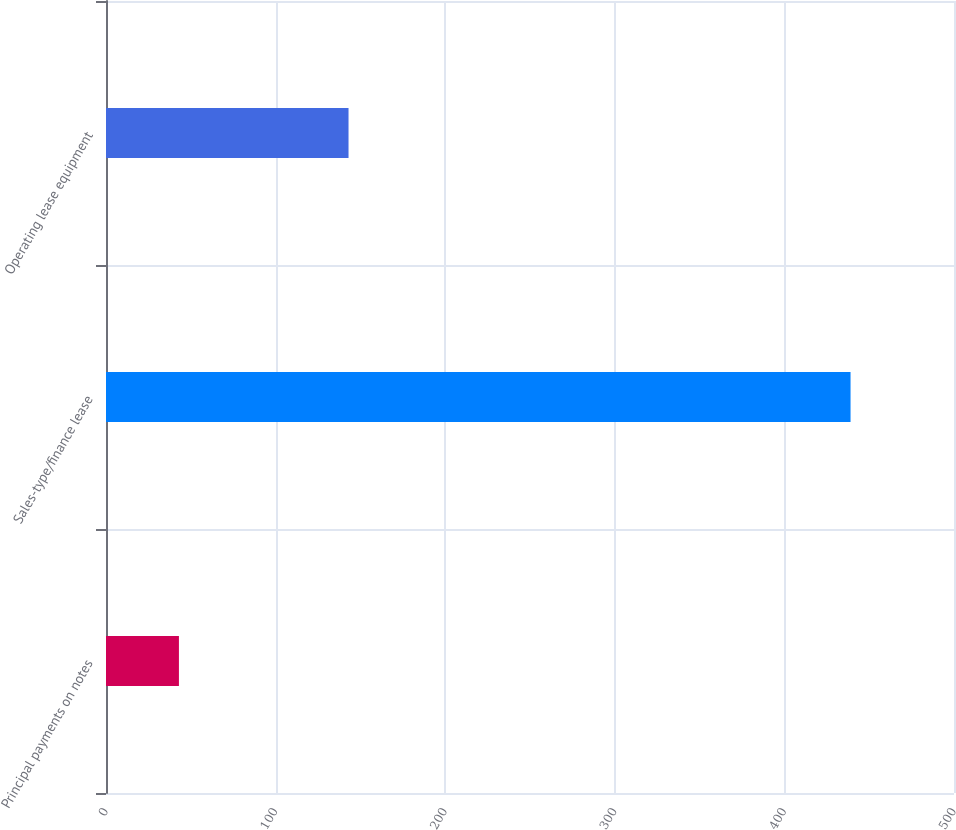<chart> <loc_0><loc_0><loc_500><loc_500><bar_chart><fcel>Principal payments on notes<fcel>Sales-type/finance lease<fcel>Operating lease equipment<nl><fcel>43<fcel>439<fcel>143<nl></chart> 